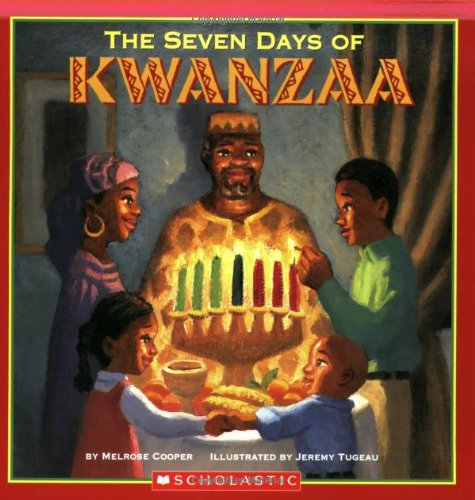How do the characters in the book appear to interact with each other? The characters in the book appear to interact warmly, sharing moments of joy and celebration which suggests a close-knit family environment emphasizing community and togetherness. 